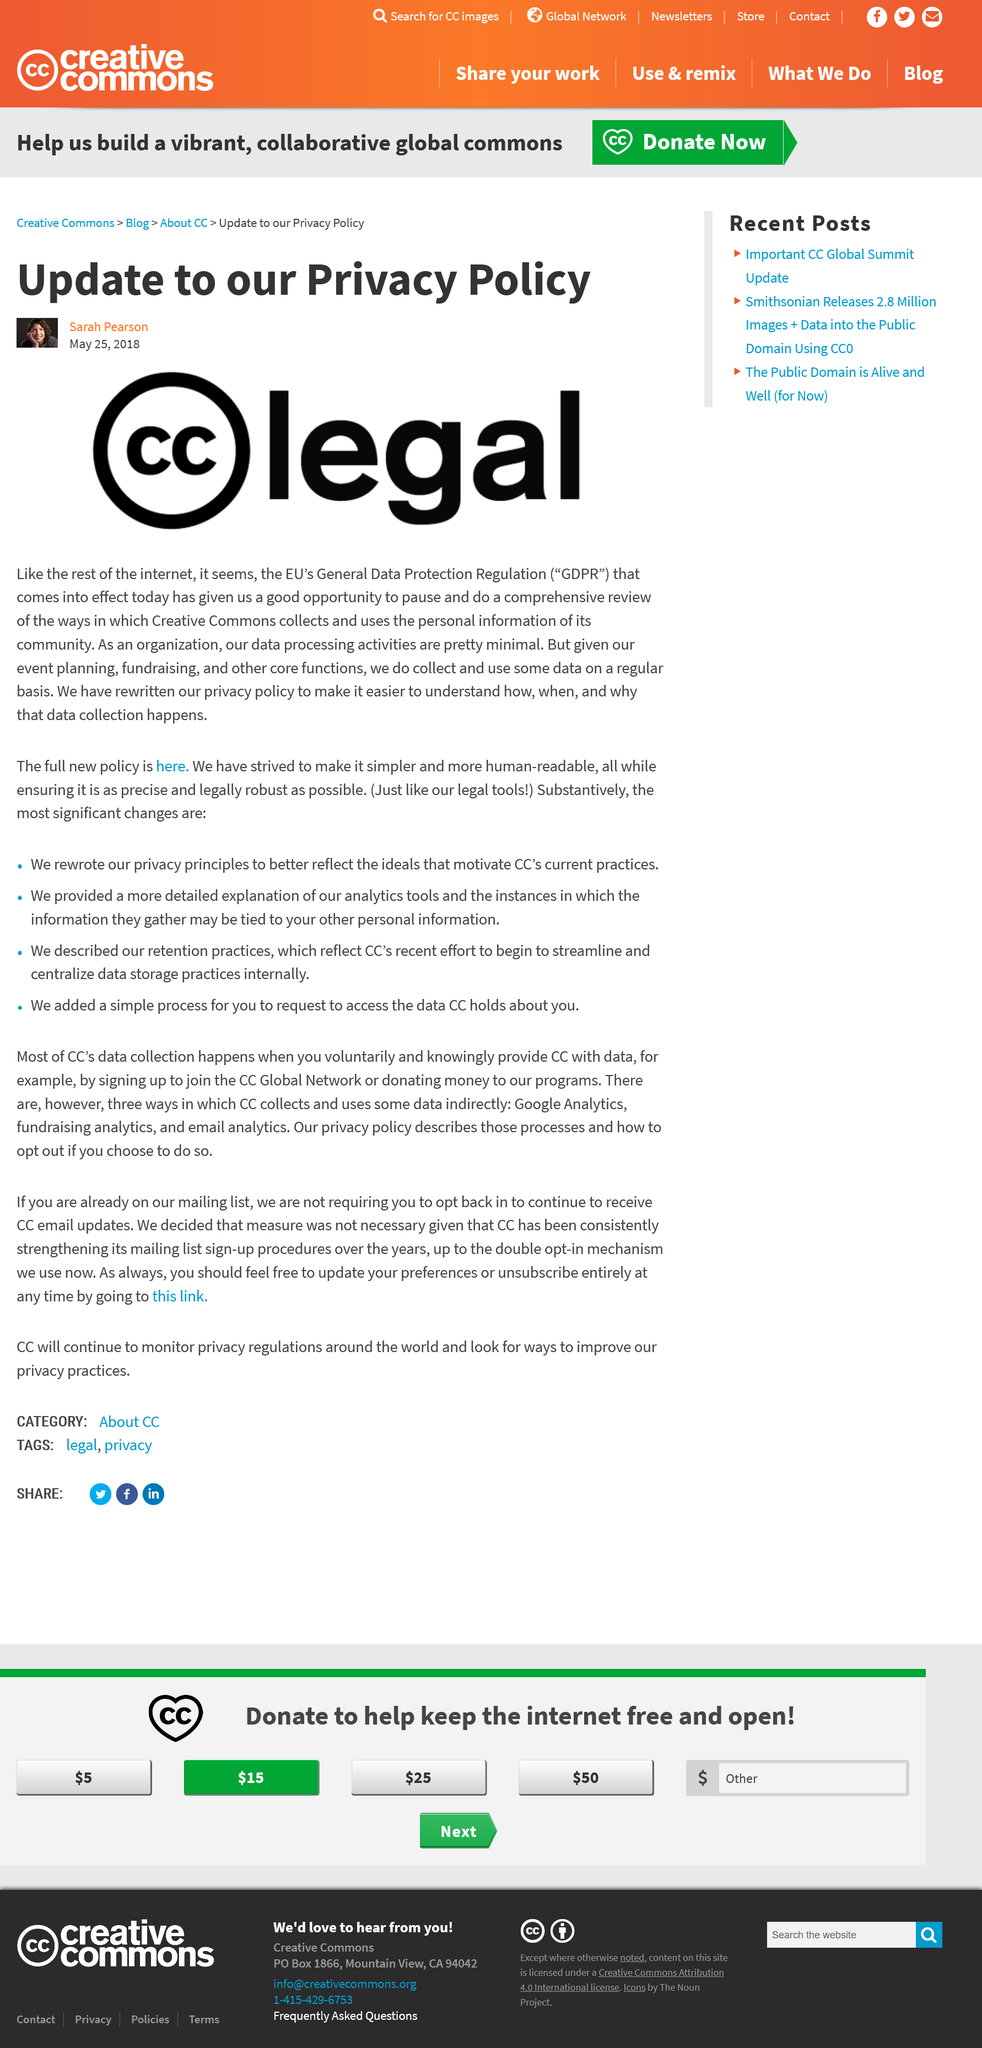Specify some key components in this picture. The author of this paragraph is a female. The symbol next to the word "legal" in the image above the paragraph is two letters "C" inside a circle. The company has rewritten their privacy policy in order to make it more comprehensive and user-friendly by providing clear information on the collection of data, including the reasons, methods, and times of data collection. 